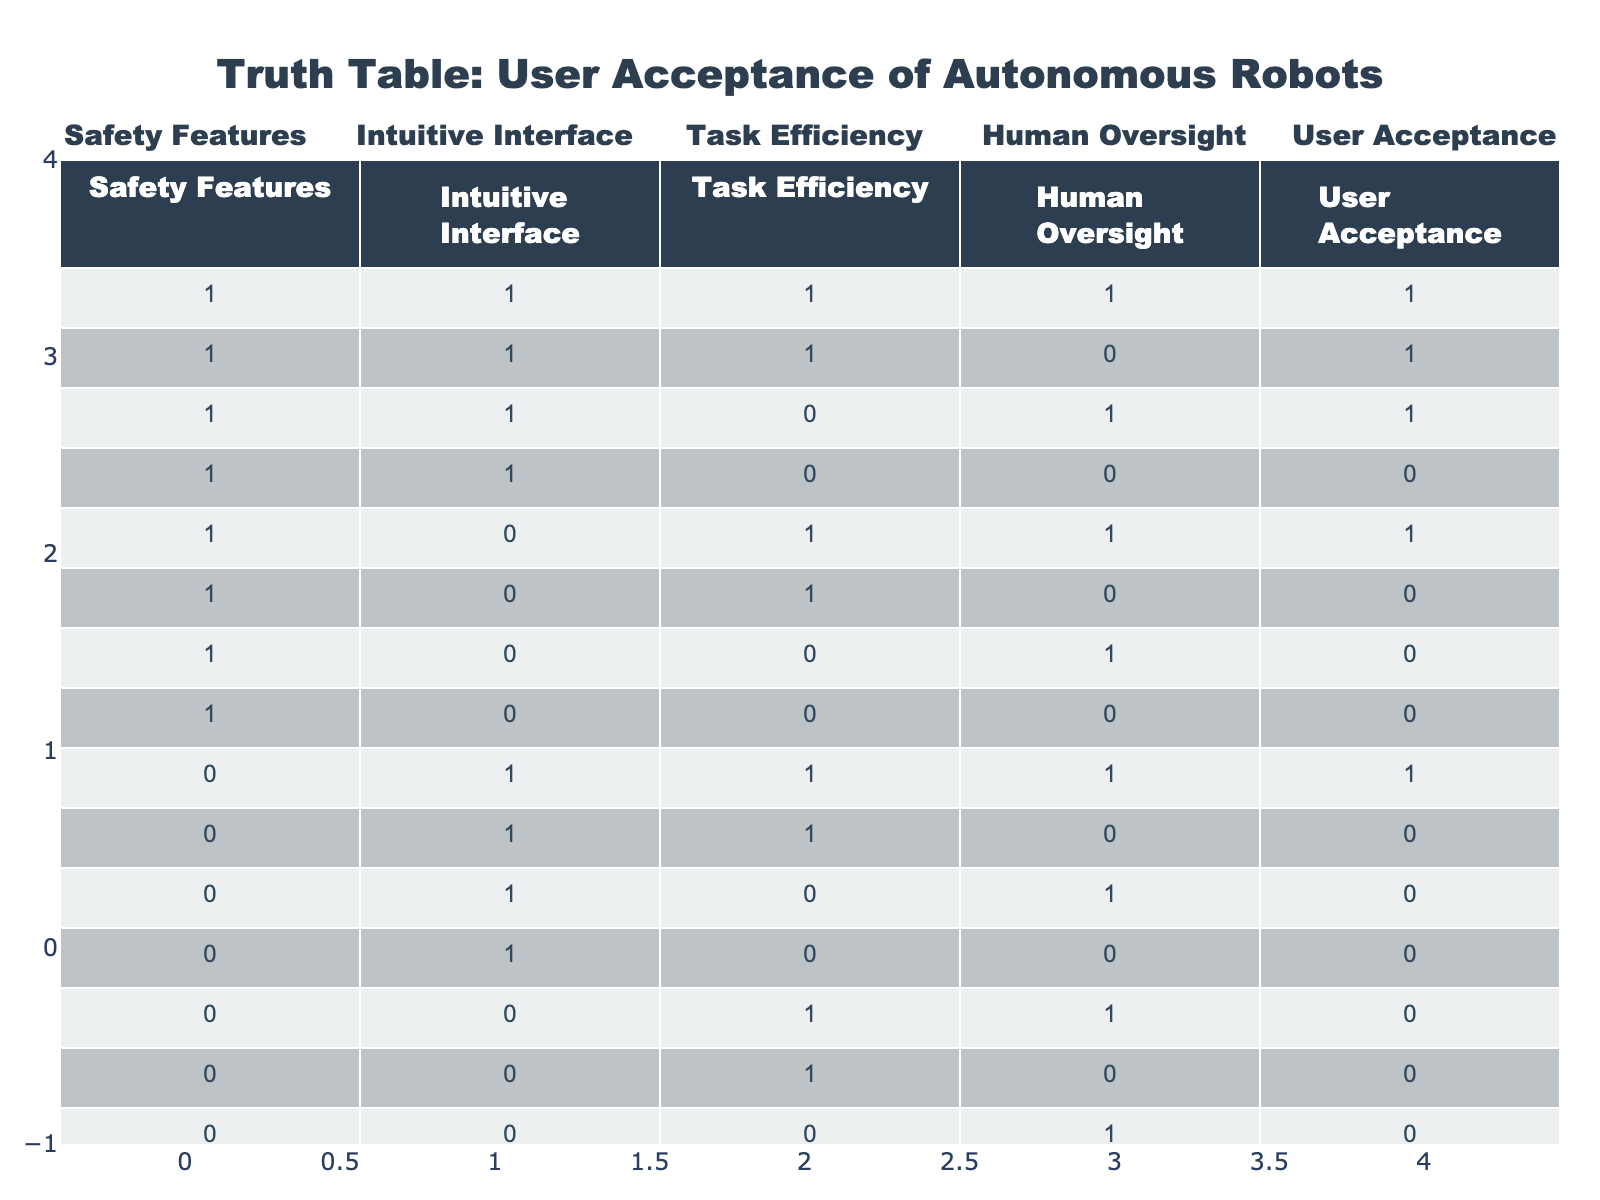What is the maximum user acceptance score in the table? The maximum user acceptance score is 1, as observed in multiple rows within the table.
Answer: 1 How many conditions lead to user acceptance in the presence of a safety feature? There are 6 rows where the safety feature is present (value 1), and user acceptance is also 1 in those cases.
Answer: 6 Is user acceptance possible without human oversight? Yes, user acceptance is possible without human oversight, as shown in the rows where human oversight is 0 and user acceptance is still 1.
Answer: Yes What is the average user acceptance score when the interface is intuitive? There are 5 cases with an intuitive interface (value 1) and the corresponding user acceptance scores are: 1, 1, 1, 0, 1. The sum is 4, and the average is 4/5 = 0.8.
Answer: 0.8 What specific combination of features results in user acceptance when task efficiency is 0 and human oversight is 1? The only row that meets these conditions is (1, 1, 0, 1) which results in a user acceptance score of 1.
Answer: (1, 1, 0, 1) How many rows have both safety features and task efficiency present yet do not lead to user acceptance? There is one row where safety features and task efficiency are both present, but they do not lead to user acceptance: (1, 1, 0, 0).
Answer: 1 Does having no safety features guarantee a user acceptance score of 0? No, there are rows without safety features where user acceptance is still scored as 1, like the row (0, 1, 1, 1).
Answer: No What can be concluded about user acceptance when all conditions score 0? When all conditions score 0, user acceptance is also 0, which indicates that no acceptance is possible under this scenario.
Answer: 0 